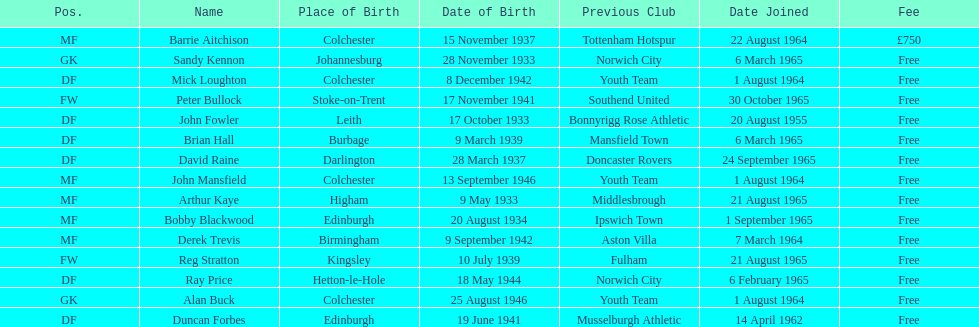Which team was ray price on before he started for this team? Norwich City. 